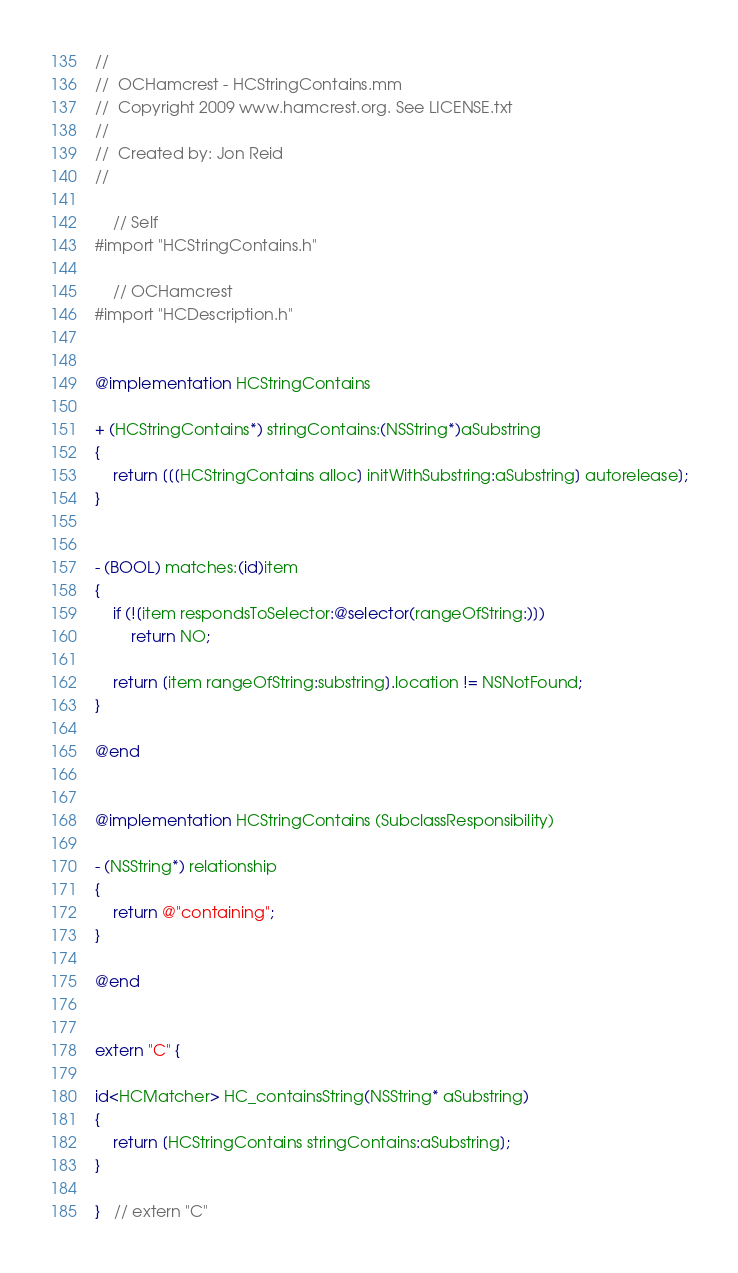<code> <loc_0><loc_0><loc_500><loc_500><_ObjectiveC_>//
//  OCHamcrest - HCStringContains.mm
//  Copyright 2009 www.hamcrest.org. See LICENSE.txt
//
//  Created by: Jon Reid
//

    // Self
#import "HCStringContains.h"

    // OCHamcrest
#import "HCDescription.h"


@implementation HCStringContains

+ (HCStringContains*) stringContains:(NSString*)aSubstring
{
    return [[[HCStringContains alloc] initWithSubstring:aSubstring] autorelease];
}


- (BOOL) matches:(id)item
{
    if (![item respondsToSelector:@selector(rangeOfString:)])
        return NO;
    
    return [item rangeOfString:substring].location != NSNotFound;
}

@end


@implementation HCStringContains (SubclassResponsibility)

- (NSString*) relationship
{
    return @"containing";
}

@end


extern "C" {

id<HCMatcher> HC_containsString(NSString* aSubstring)
{
    return [HCStringContains stringContains:aSubstring];
}

}   // extern "C"
</code> 